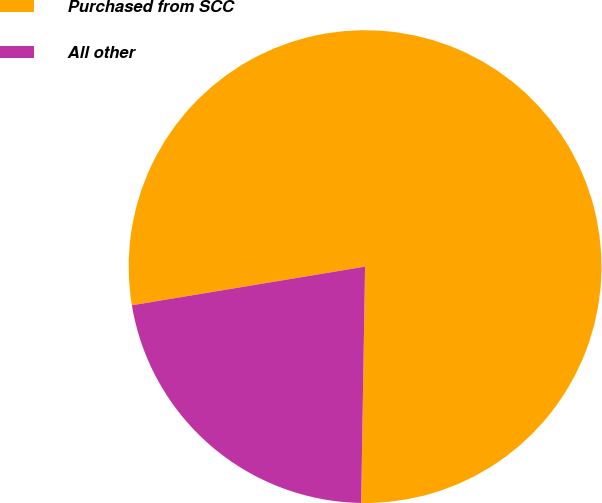Convert chart to OTSL. <chart><loc_0><loc_0><loc_500><loc_500><pie_chart><fcel>Purchased from SCC<fcel>All other<nl><fcel>77.88%<fcel>22.12%<nl></chart> 